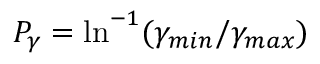Convert formula to latex. <formula><loc_0><loc_0><loc_500><loc_500>P _ { \gamma } = \ln ^ { - 1 } ( \gamma _ { \min } / \gamma _ { \max } )</formula> 